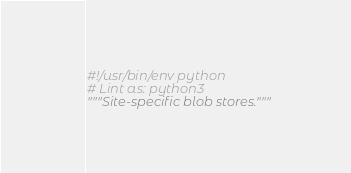<code> <loc_0><loc_0><loc_500><loc_500><_Python_>#!/usr/bin/env python
# Lint as: python3
"""Site-specific blob stores."""
</code> 